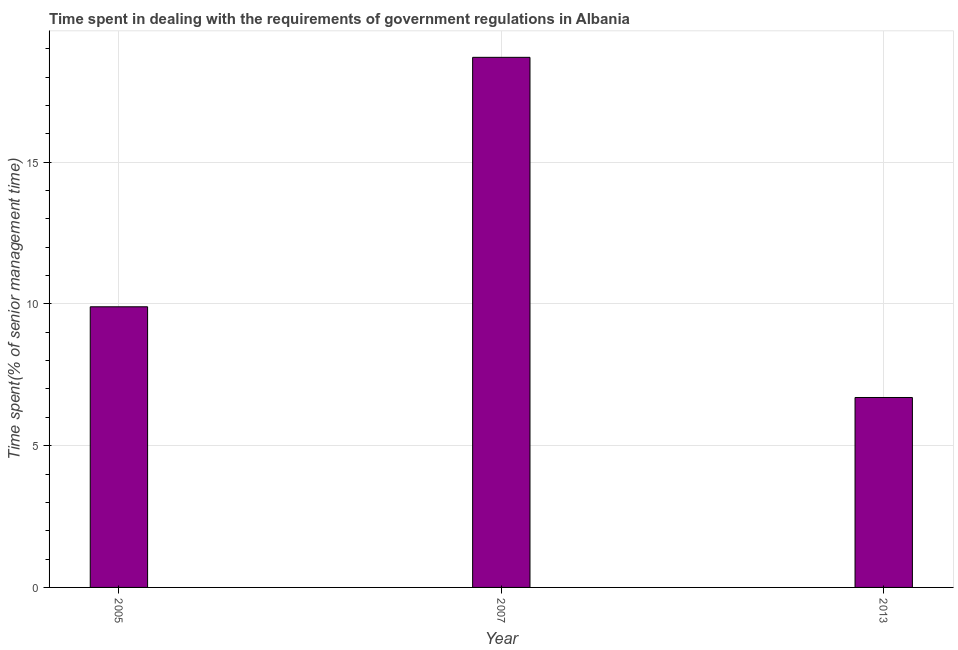Does the graph contain grids?
Make the answer very short. Yes. What is the title of the graph?
Ensure brevity in your answer.  Time spent in dealing with the requirements of government regulations in Albania. What is the label or title of the X-axis?
Provide a succinct answer. Year. What is the label or title of the Y-axis?
Ensure brevity in your answer.  Time spent(% of senior management time). What is the time spent in dealing with government regulations in 2007?
Offer a terse response. 18.7. Across all years, what is the maximum time spent in dealing with government regulations?
Your answer should be very brief. 18.7. In which year was the time spent in dealing with government regulations minimum?
Your answer should be very brief. 2013. What is the sum of the time spent in dealing with government regulations?
Provide a short and direct response. 35.3. What is the average time spent in dealing with government regulations per year?
Provide a short and direct response. 11.77. In how many years, is the time spent in dealing with government regulations greater than 1 %?
Offer a terse response. 3. Do a majority of the years between 2007 and 2013 (inclusive) have time spent in dealing with government regulations greater than 8 %?
Your answer should be compact. No. What is the ratio of the time spent in dealing with government regulations in 2007 to that in 2013?
Offer a terse response. 2.79. Is the time spent in dealing with government regulations in 2007 less than that in 2013?
Ensure brevity in your answer.  No. Is the sum of the time spent in dealing with government regulations in 2005 and 2013 greater than the maximum time spent in dealing with government regulations across all years?
Your response must be concise. No. In how many years, is the time spent in dealing with government regulations greater than the average time spent in dealing with government regulations taken over all years?
Keep it short and to the point. 1. How many bars are there?
Make the answer very short. 3. Are all the bars in the graph horizontal?
Your answer should be compact. No. How many years are there in the graph?
Your answer should be compact. 3. Are the values on the major ticks of Y-axis written in scientific E-notation?
Give a very brief answer. No. What is the Time spent(% of senior management time) of 2005?
Offer a terse response. 9.9. What is the Time spent(% of senior management time) of 2007?
Offer a terse response. 18.7. What is the Time spent(% of senior management time) of 2013?
Your answer should be very brief. 6.7. What is the difference between the Time spent(% of senior management time) in 2005 and 2007?
Keep it short and to the point. -8.8. What is the difference between the Time spent(% of senior management time) in 2005 and 2013?
Ensure brevity in your answer.  3.2. What is the ratio of the Time spent(% of senior management time) in 2005 to that in 2007?
Your answer should be compact. 0.53. What is the ratio of the Time spent(% of senior management time) in 2005 to that in 2013?
Provide a succinct answer. 1.48. What is the ratio of the Time spent(% of senior management time) in 2007 to that in 2013?
Keep it short and to the point. 2.79. 